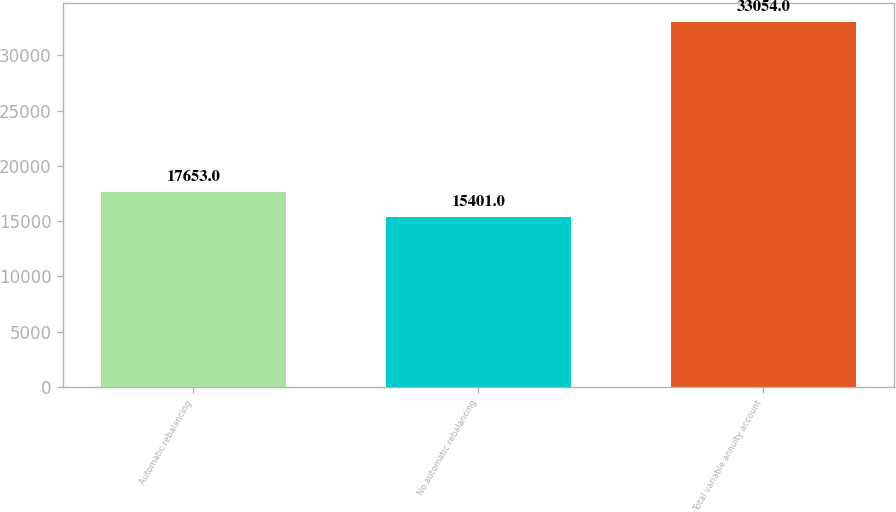Convert chart. <chart><loc_0><loc_0><loc_500><loc_500><bar_chart><fcel>Automatic rebalancing<fcel>No automatic rebalancing<fcel>Total variable annuity account<nl><fcel>17653<fcel>15401<fcel>33054<nl></chart> 